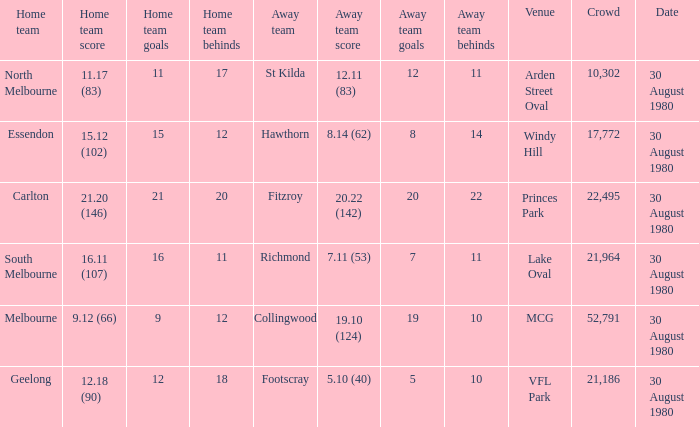Can you give me this table as a dict? {'header': ['Home team', 'Home team score', 'Home team goals', 'Home team behinds', 'Away team', 'Away team score', 'Away team goals', 'Away team behinds', 'Venue', 'Crowd', 'Date'], 'rows': [['North Melbourne', '11.17 (83)', '11', '17', 'St Kilda', '12.11 (83)', '12', '11', 'Arden Street Oval', '10,302', '30 August 1980'], ['Essendon', '15.12 (102)', '15', '12', 'Hawthorn', '8.14 (62)', '8', '14', 'Windy Hill', '17,772', '30 August 1980'], ['Carlton', '21.20 (146)', '21', '20', 'Fitzroy', '20.22 (142)', '20', '22', 'Princes Park', '22,495', '30 August 1980'], ['South Melbourne', '16.11 (107)', '16', '11', 'Richmond', '7.11 (53)', '7', '11', 'Lake Oval', '21,964', '30 August 1980'], ['Melbourne', '9.12 (66)', '9', '12', 'Collingwood', '19.10 (124)', '19', '10', 'MCG', '52,791', '30 August 1980'], ['Geelong', '12.18 (90)', '12', '18', 'Footscray', '5.10 (40)', '5', '10', 'VFL Park', '21,186', '30 August 1980']]} What was the score for south melbourne at home? 16.11 (107). 